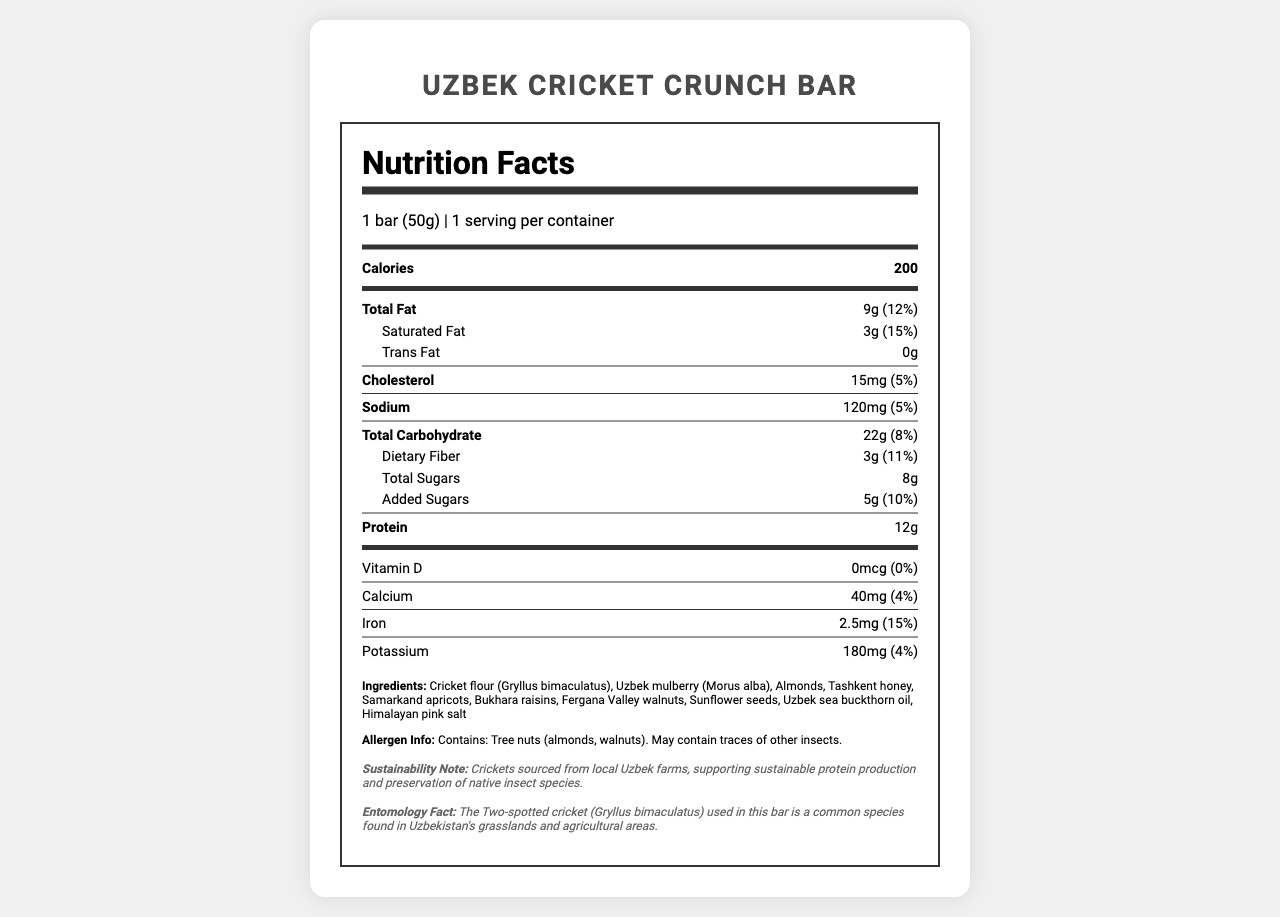how many servings per container are there? The document states that there is 1 serving per container.
Answer: 1 how much protein does the Uzbek Cricket Crunch Bar contain? The nutrition label lists the protein content as 12g.
Answer: 12g how many grams of dietary fiber are in the bar? The dietary fiber content is specified as 3g on the nutrition label.
Answer: 3g what are the main ingredients in the Uzbek Cricket Crunch Bar? The main ingredients are listed under the "Ingredients" section.
Answer: Cricket flour, Uzbek mulberry, Almonds, Tashkent honey, Samarkand apricots, Bukhara raisins, Fergana Valley walnuts, Sunflower seeds, Uzbek sea buckthorn oil, Himalayan pink salt how much calcium is in one serving of the bar? The label indicates that each serving contains 40mg of calcium.
Answer: 40mg what is the source of protein in the Uzbek Cricket Crunch Bar? A. Soy B. Cricket flour C. Whey D. Pea protein The protein source is cricket flour, as listed among the ingredients.
Answer: B what is the daily value percentage of iron in the bar? A. 5% B. 10% C. 15% D. 20% The iron daily value is 15%, as outlined in the nutrition facts.
Answer: C does the Uzbek Cricket Crunch Bar contain any tree nuts? The allergen info states that the bar contains almonds and walnuts, which are tree nuts.
Answer: Yes does the bar contain any added sugars? The nutrition label lists 5g of added sugars.
Answer: Yes give a short summary of the document. The document offers comprehensive nutritional information and highlights the sustainable and local aspects of the ingredients, alongside providing insights into the entomology of the cricket species used.
Answer: The document provides the nutrition facts for the Uzbek Cricket Crunch Bar, which includes calorie count, macronutrient contents, and micronutrients. It details the ingredients, allergen information, sustainability note, and an entomology fact about the cricket species used. what is the significance of using Two-spotted crickets in the bar? The document does not provide enough information to determine the significance of using Two-spotted crickets in the bar beyond the fact that they are sourced from local farms and are a common species found in Uzbekistan.
Answer: Not enough information 